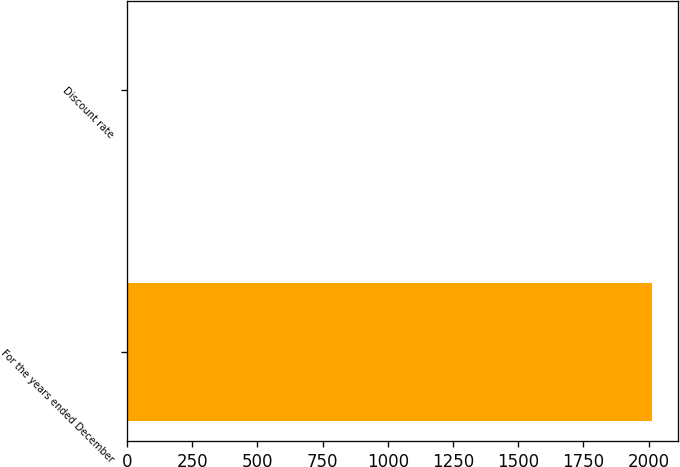Convert chart. <chart><loc_0><loc_0><loc_500><loc_500><bar_chart><fcel>For the years ended December<fcel>Discount rate<nl><fcel>2014<fcel>4.5<nl></chart> 